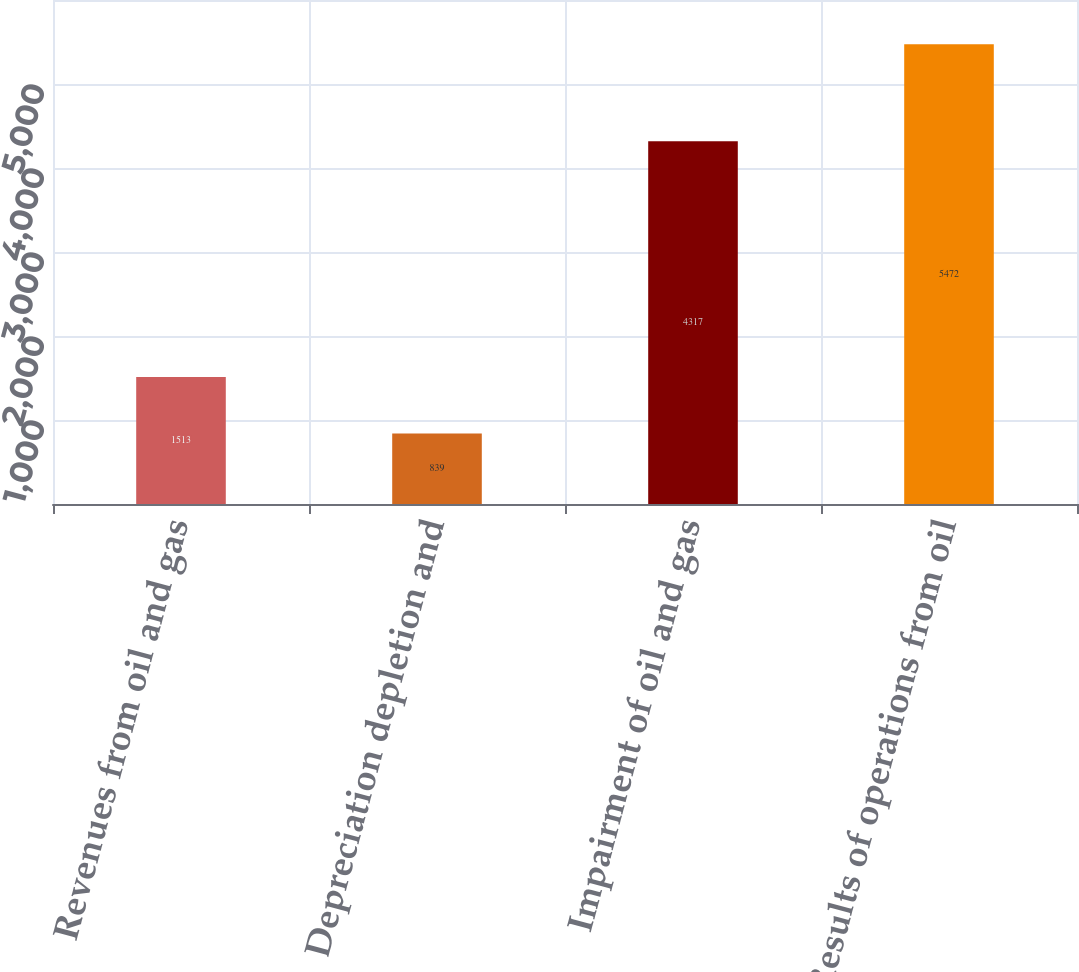Convert chart to OTSL. <chart><loc_0><loc_0><loc_500><loc_500><bar_chart><fcel>Revenues from oil and gas<fcel>Depreciation depletion and<fcel>Impairment of oil and gas<fcel>Results of operations from oil<nl><fcel>1513<fcel>839<fcel>4317<fcel>5472<nl></chart> 